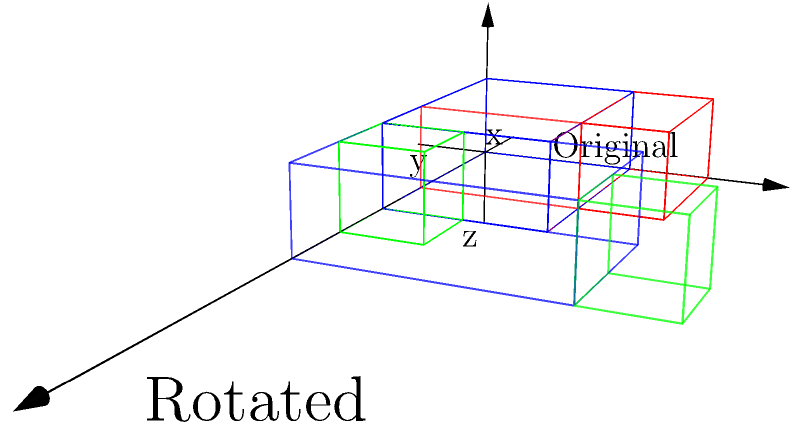In the diagram, a museum exhibit layout is shown before and after a 90-degree rotation around the z-axis. If the blue exhibit originally had dimensions of 3x2x1 units (length x width x height), what are its new dimensions after the rotation? To solve this problem, we need to follow these steps:

1. Identify the original dimensions of the blue exhibit:
   Length (x) = 3 units
   Width (y) = 2 units
   Height (z) = 1 unit

2. Understand the rotation:
   The exhibit is rotated 90 degrees around the z-axis (vertical axis).

3. Analyze the effect of the rotation:
   - The z-dimension (height) remains unchanged.
   - The x and y dimensions swap.

4. Determine the new dimensions:
   - New length (x) = Original width = 2 units
   - New width (y) = Original length = 3 units
   - New height (z) = Original height = 1 unit

Therefore, after the 90-degree rotation around the z-axis, the blue exhibit's new dimensions are 2x3x1 units (length x width x height).
Answer: 2x3x1 units 